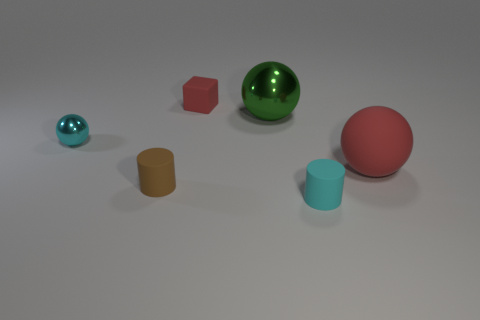Can you describe the arrangement of objects on this surface? Certainly! On the surface, the objects are arranged with a sense of random placement but with enough space between them to distinguish each object's shape and color clearly. Starting from the left, there's a small cyan sphere, followed by a medium-sized red cube, a large green sphere, and a pink ball with a slightly matte texture. On the far right, there are two cylinders - a tall orange one with a wider base and a shorter blue one with a narrow base. 